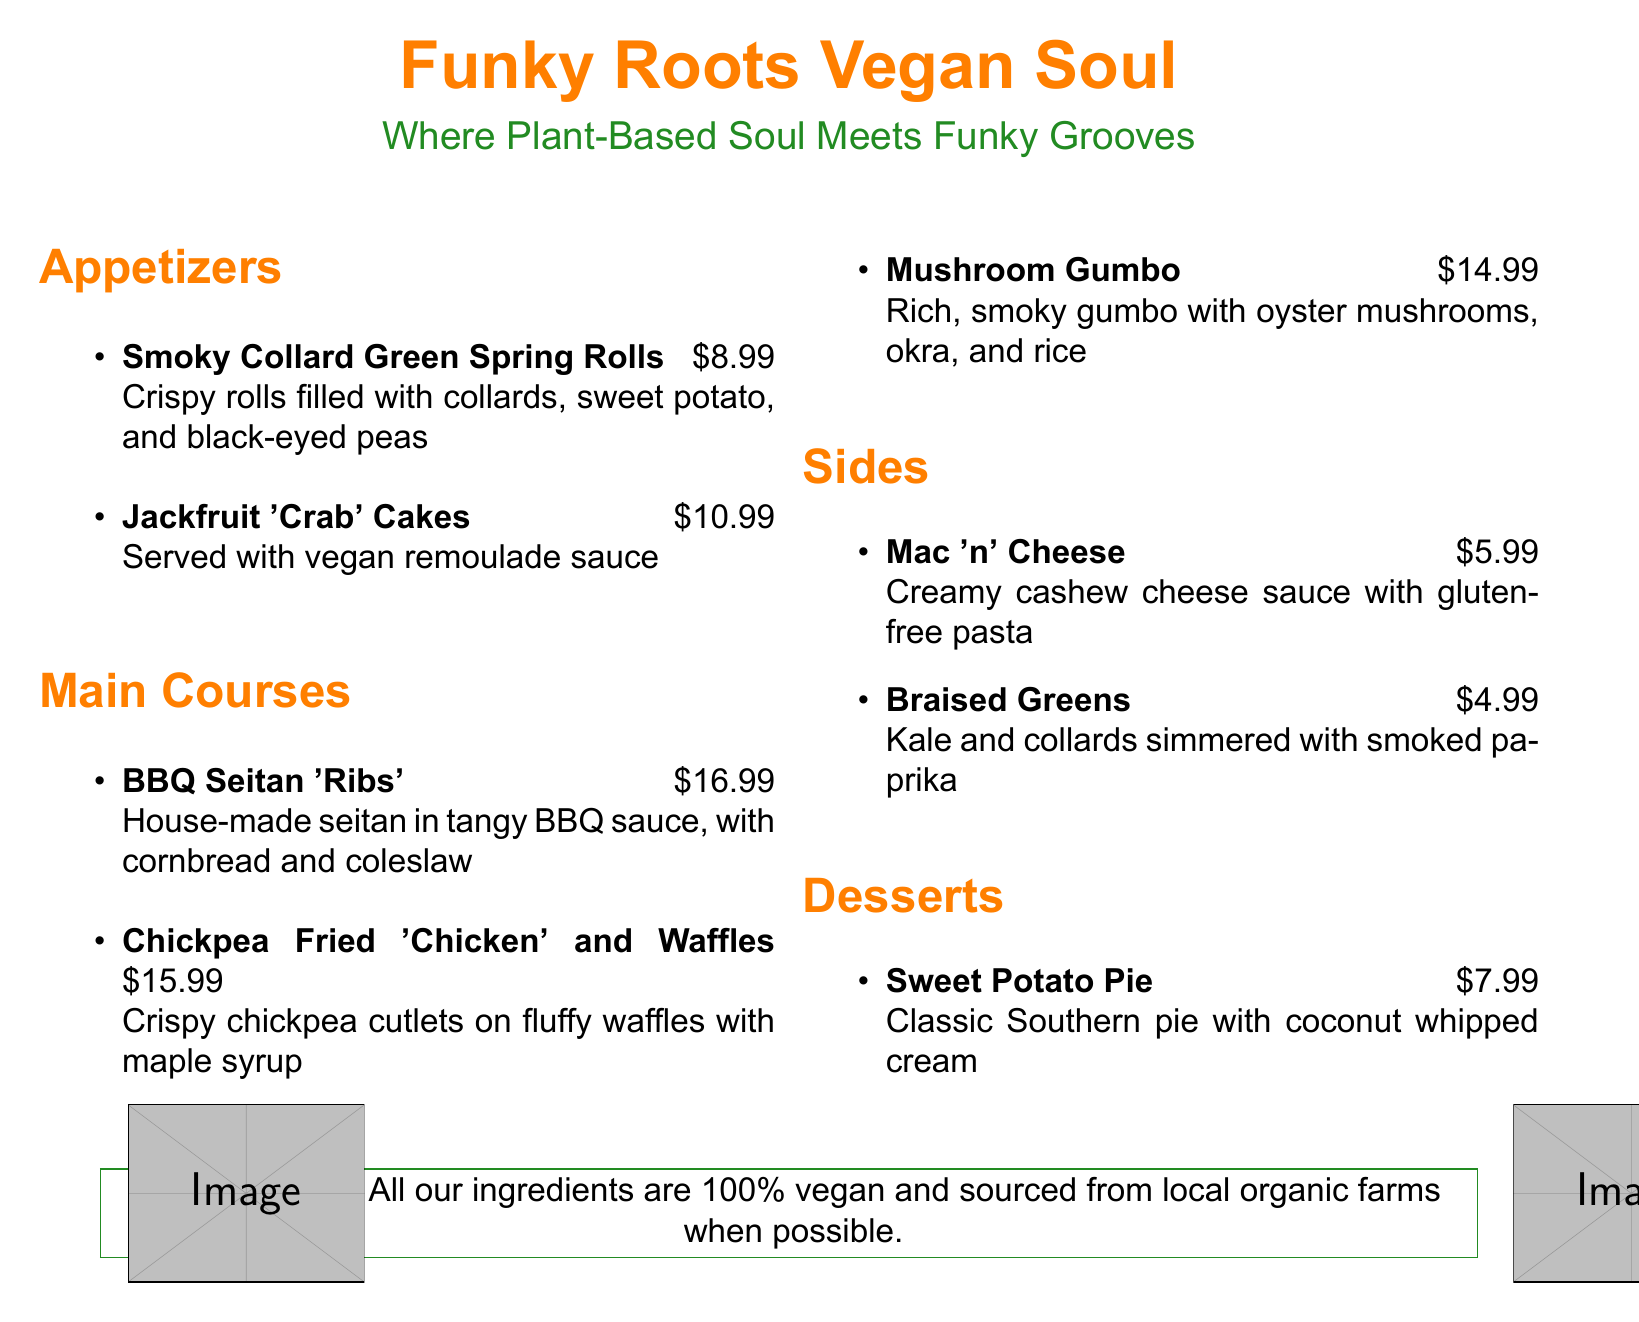What is the price of the Smoky Collard Green Spring Rolls? The price of the Smoky Collard Green Spring Rolls is listed in the appetizers section of the menu.
Answer: $8.99 How many main courses are listed on the menu? The main courses section has three items listed, which can be counted for the answer.
Answer: 3 What is the special note emphasized on the menu? The special note explains that all ingredients are 100% vegan and sourced from local organic farms.
Answer: 100% vegan and sourced from local organic farms Which dessert is available at the restaurant? The dessert section only lists one item, which is the Sweet Potato Pie.
Answer: Sweet Potato Pie What is the main ingredient in the Chickpea Fried 'Chicken'? The primary ingredient of the Chickpea Fried 'Chicken' dish is mentioned in the description.
Answer: Chickpea What is the color theme used for the restaurant name? The restaurant name is stylized with a specific color, which is defined at the beginning of the document.
Answer: Funky orange What two sides are offered on the menu? The sides section includes two items that can be found listed there.
Answer: Mac 'n' Cheese, Braised Greens What is the total price for Jackfruit 'Crab' Cakes and Mushroom Gumbo? The total price is calculated by adding the prices of both dishes from the menu.
Answer: $25.98 